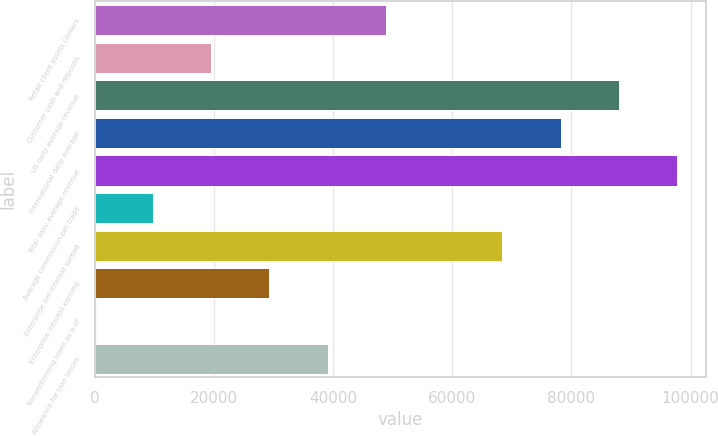Convert chart. <chart><loc_0><loc_0><loc_500><loc_500><bar_chart><fcel>Retail client assets (dollars<fcel>Customer cash and deposits<fcel>US daily average revenue<fcel>International daily average<fcel>Total daily average revenue<fcel>Average commission per trade<fcel>Enterprise net interest spread<fcel>Enterprise interest-earning<fcel>Nonperforming loans as a of<fcel>Allowance for loan losses<nl><fcel>48870.1<fcel>19548.1<fcel>87966<fcel>78192<fcel>97740<fcel>9774.15<fcel>68418<fcel>29322.1<fcel>0.17<fcel>39096.1<nl></chart> 